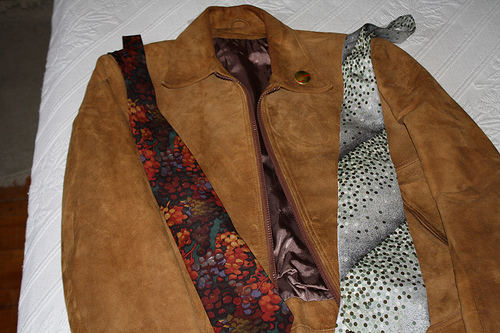<image>
Is the tie on the tie? No. The tie is not positioned on the tie. They may be near each other, but the tie is not supported by or resting on top of the tie. 